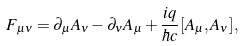Convert formula to latex. <formula><loc_0><loc_0><loc_500><loc_500>F _ { \mu \nu } = \partial _ { \mu } A _ { \nu } - \partial _ { \nu } A _ { \mu } + \frac { i q } { \hbar { c } } [ A _ { \mu } , A _ { \nu } ] ,</formula> 